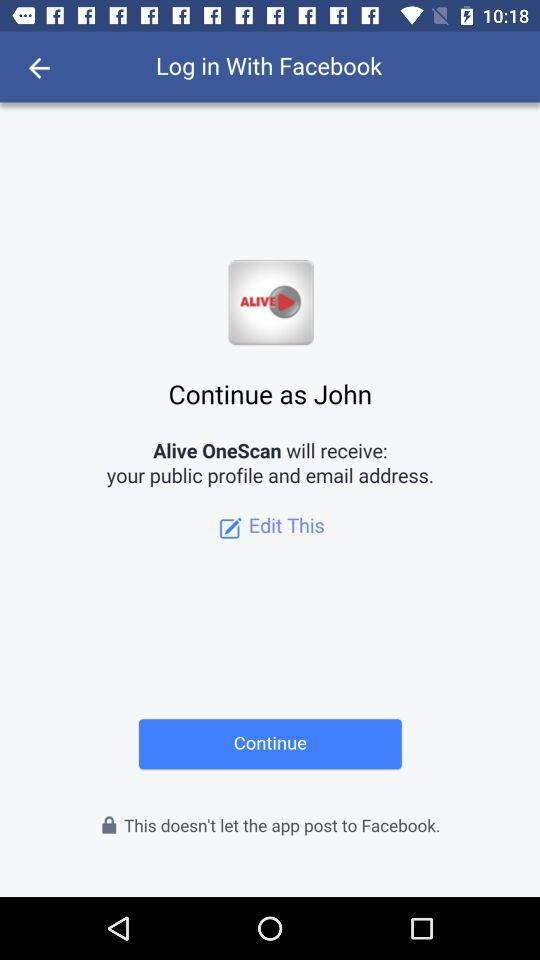What is the login name? The login name is John. 